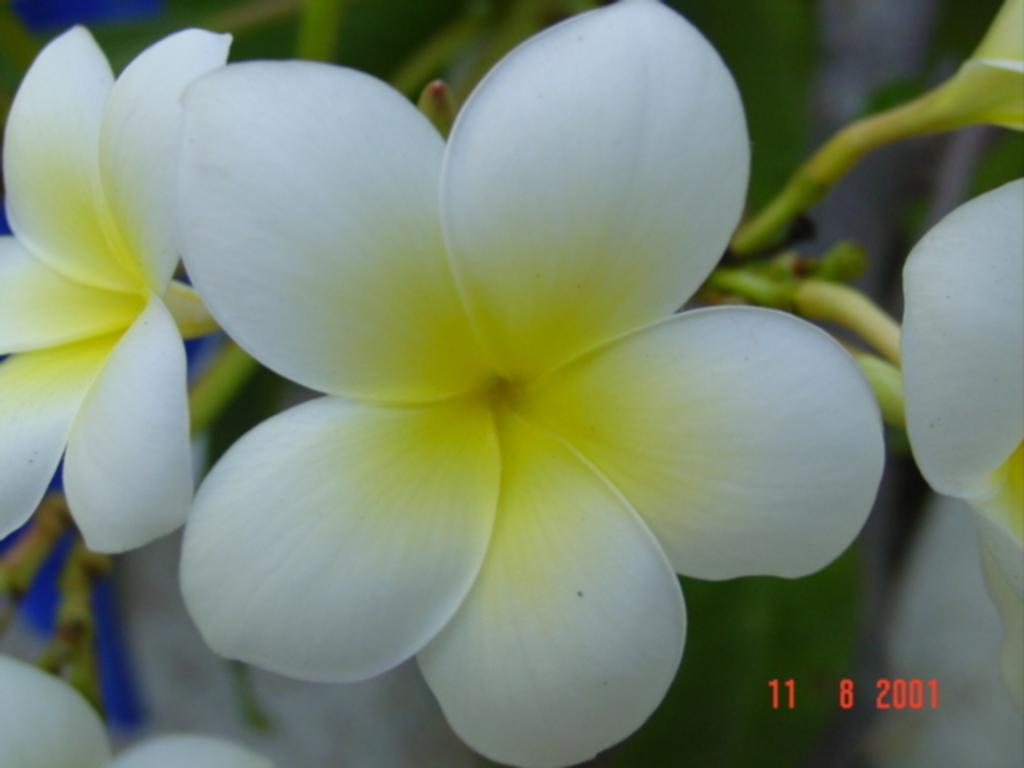In one or two sentences, can you explain what this image depicts? In this image, we can see a plant with flowers and buds. At the bottom, there is some text. 